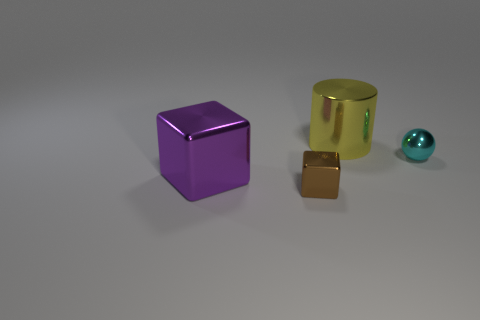Does the big object that is behind the purple shiny object have the same shape as the purple thing?
Your response must be concise. No. What number of metallic objects are blocks or big yellow cylinders?
Offer a terse response. 3. Is there a cyan thing of the same size as the brown metal object?
Ensure brevity in your answer.  Yes. Is the number of tiny shiny objects to the left of the small cyan ball greater than the number of blue shiny cubes?
Your answer should be compact. Yes. How many large objects are either yellow cylinders or green balls?
Offer a very short reply. 1. What number of other shiny objects are the same shape as the brown metal object?
Your answer should be very brief. 1. There is a big thing on the left side of the object that is in front of the large purple metallic object; what is it made of?
Offer a very short reply. Metal. How big is the metallic cube to the left of the tiny cube?
Provide a succinct answer. Large. What number of purple things are cubes or big cylinders?
Give a very brief answer. 1. Are there the same number of tiny cyan objects that are left of the big shiny cube and tiny cyan metal things?
Keep it short and to the point. No. 